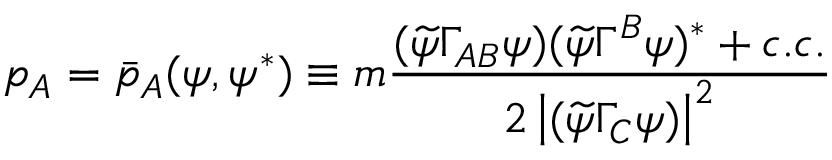Convert formula to latex. <formula><loc_0><loc_0><loc_500><loc_500>p _ { A } = \bar { p } _ { A } ( \psi , \psi ^ { * } ) \equiv m \frac { ( \widetilde { \psi } \Gamma _ { A B } \psi ) ( \widetilde { \psi } \Gamma ^ { B } \psi ) ^ { * } + c . c . } { 2 \left | ( \widetilde { \psi } \Gamma _ { C } \psi ) \right | ^ { 2 } }</formula> 